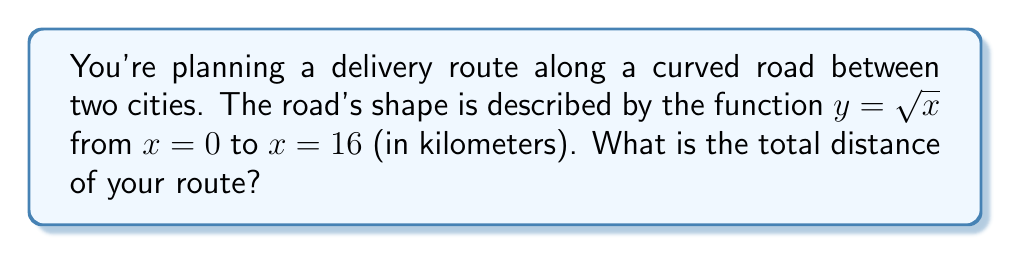Could you help me with this problem? To find the total distance along a curved path, we need to use the arc length formula from integral calculus. Here's how we solve this step-by-step:

1) The arc length formula for a function $y = f(x)$ from $a$ to $b$ is:

   $$L = \int_a^b \sqrt{1 + \left(\frac{dy}{dx}\right)^2} dx$$

2) In our case, $y = \sqrt{x}$, $a = 0$, and $b = 16$.

3) First, we need to find $\frac{dy}{dx}$:
   
   $$\frac{dy}{dx} = \frac{1}{2\sqrt{x}}$$

4) Now, let's substitute this into our arc length formula:

   $$L = \int_0^{16} \sqrt{1 + \left(\frac{1}{2\sqrt{x}}\right)^2} dx$$

5) Simplify the expression under the square root:

   $$L = \int_0^{16} \sqrt{1 + \frac{1}{4x}} dx$$

6) This integral is not easy to solve by hand. We can use the substitution $u = \sqrt{x}$ to simplify it:

   $$L = 2\int_0^4 \sqrt{1 + \frac{1}{4u^2}} \cdot 2u du = 4\int_0^4 \sqrt{u^2 + \frac{1}{4}} du$$

7) This is now in the form of $\int \sqrt{u^2 + a^2} du$, which has a known solution:

   $$\frac{u}{2}\sqrt{u^2 + a^2} + \frac{a^2}{2}\ln(u + \sqrt{u^2 + a^2}) + C$$

8) Applying this to our integral with $a = \frac{1}{2}$:

   $$L = 4\left[\frac{u}{2}\sqrt{u^2 + \frac{1}{4}} + \frac{1}{8}\ln(u + \sqrt{u^2 + \frac{1}{4}})\right]_0^4$$

9) Evaluating at the limits:

   $$L = 4\left[2\sqrt{16 + \frac{1}{4}} + \frac{1}{8}\ln(4 + \sqrt{16 + \frac{1}{4}}) - 0\right]$$

10) Simplifying:

    $$L = 4\left[2\sqrt{\frac{65}{4}} + \frac{1}{8}\ln(4 + \sqrt{\frac{65}{4}})\right] \approx 16.39 \text{ km}$$
Answer: 16.39 km 